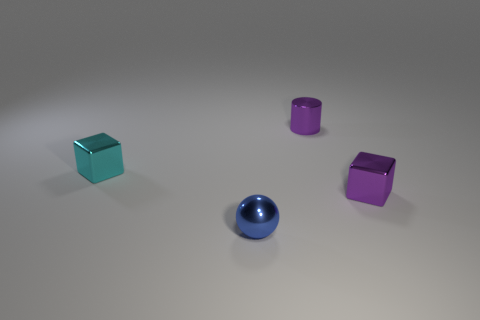How many shiny things are either tiny balls or small green blocks? The image presents a diverse collection of glossy objects, including a total of two small cubes and two spherical balls. Specific to your question, there is one small green cube and no tiny balls, leading to a count of one object fitting the description of 'tiny balls or small green blocks'. 